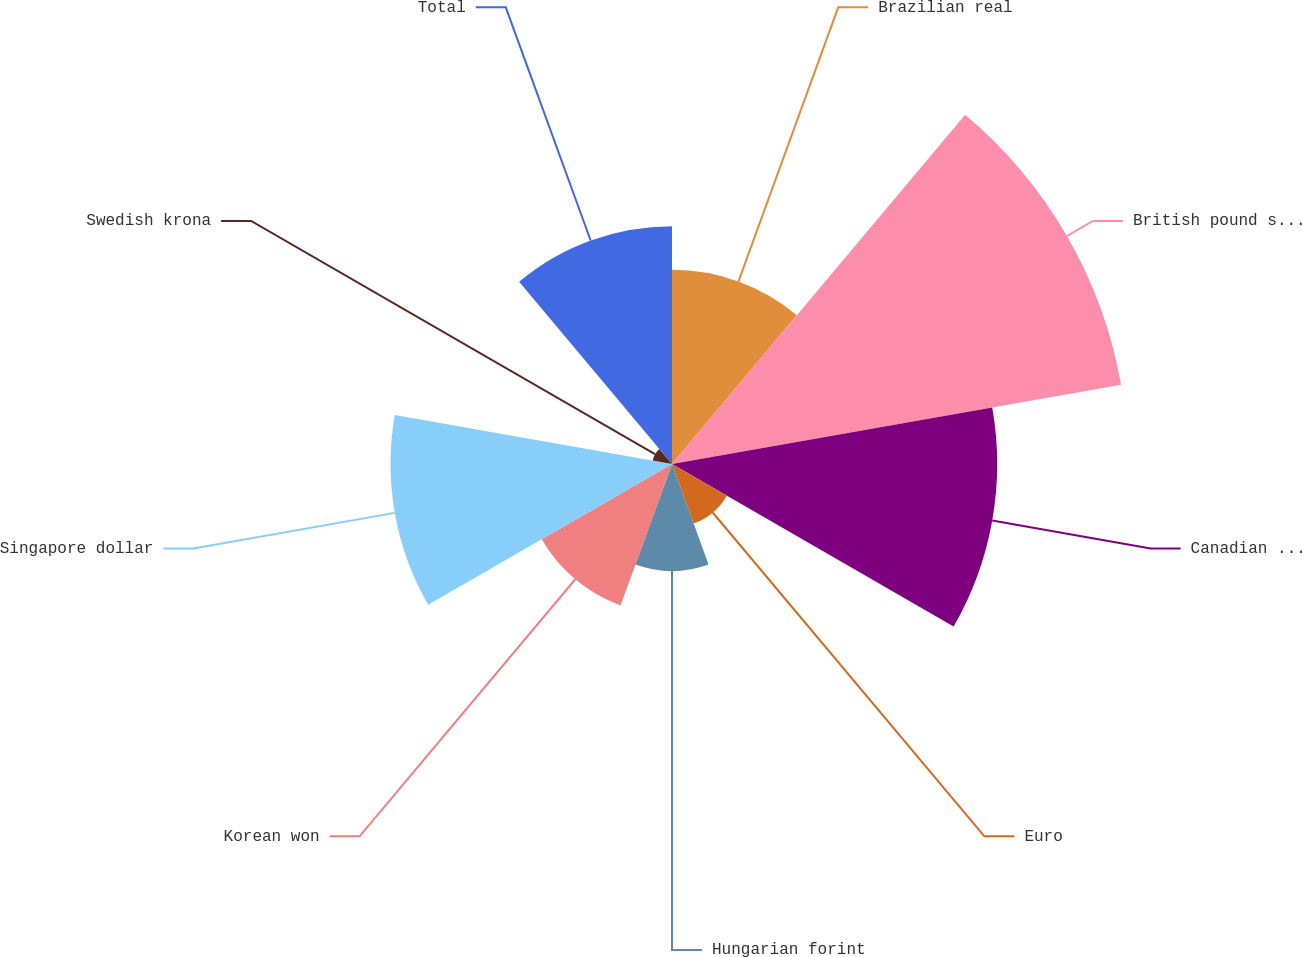Convert chart to OTSL. <chart><loc_0><loc_0><loc_500><loc_500><pie_chart><fcel>Brazilian real<fcel>British pound sterling<fcel>Canadian dollar<fcel>Euro<fcel>Hungarian forint<fcel>Korean won<fcel>Singapore dollar<fcel>Swedish krona<fcel>Total<nl><fcel>10.58%<fcel>24.85%<fcel>17.72%<fcel>3.45%<fcel>5.83%<fcel>8.2%<fcel>15.34%<fcel>1.07%<fcel>12.96%<nl></chart> 